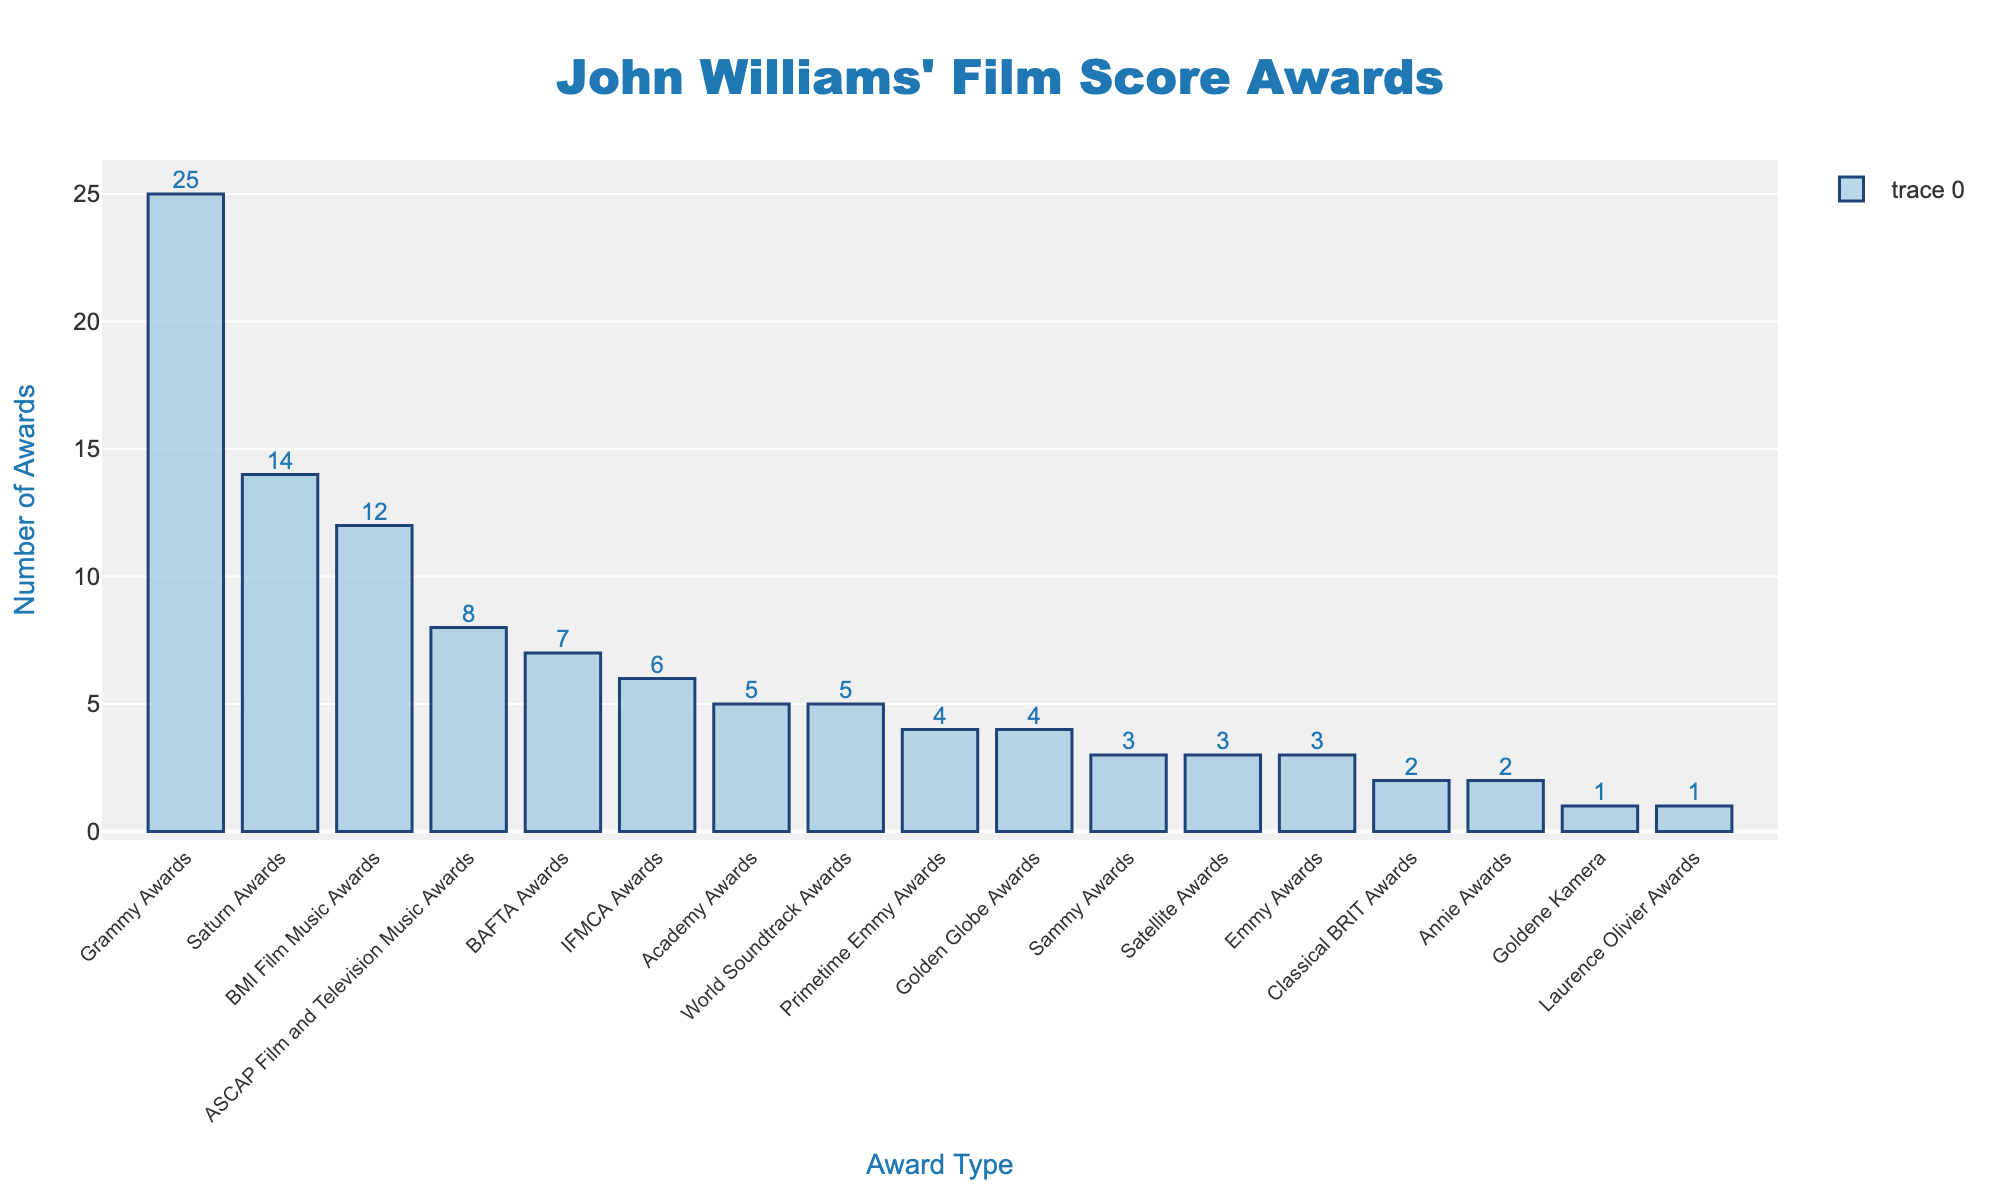What's the total number of Grammy and Saturn Awards John Williams has won? Add the number of Grammy Awards and Saturn Awards from the chart. Grammy Awards: 25; Saturn Awards: 14. Total = 25 + 14 = 39
Answer: 39 Which award type has fewer wins: Laurence Olivier Awards or Goldene Kamera? Compare the bars for Laurence Olivier Awards and Goldene Kamera. Both have exactly 1 win each, so neither has fewer wins.
Answer: Equal What is the difference in the number of awards between BAFTA Awards and ASCAP Film and Television Music Awards? Subtract the number of ASCAP Film and Television Music Awards from the number of BAFTA Awards. BAFTA Awards: 7; ASCAP Film and Television Music Awards: 8. Difference = 8 - 7 = 1
Answer: 1 Which award type does John Williams have the most wins for, and how many? Identify the tallest bar. The Grammy Awards bar is the tallest with 25 wins.
Answer: Grammy Awards with 25 wins What is the combined number of Academy Awards, Golden Globe Awards, and Emmy Awards John Williams has won? Add the number of Academy Awards, Golden Globe Awards, and Emmy Awards. Academy Awards: 5; Golden Globe Awards: 4; Emmy Awards: 3. Total = 5 + 4 + 3 = 12
Answer: 12 How many more awards has John Williams won with BMI Film Music Awards than with Primetime Emmy Awards? Subtract the number of Primetime Emmy Awards from the number of BMI Film Music Awards. BMI Film Music Awards: 12; Primetime Emmy Awards: 4. Difference = 12 - 4 = 8
Answer: 8 Which award category mentioned has the lowest number of wins and how many? Identify the shortest bar. Both Goldene Kamera and Laurence Olivier Awards are tied for the lowest number of wins with 1 each.
Answer: Goldene Kamera and Laurence Olivier Awards with 1 each How many types of awards has John Williams won exactly 3 times? And which awards are they? Count the awards with exactly 3 wins by looking at the corresponding bars. There are three: Emmy Awards, Satellite Awards, Samuel Awards.
Answer: 3 awards - Emmy Awards, Satellite Awards, Sammy Awards What's the sum of the number of World Soundtrack Awards and IFMCA Awards? Add the number of World Soundtrack Awards and IFMCA Awards. World Soundtrack Awards: 5; IFMCA Awards: 6. Total = 5 + 6 = 11
Answer: 11 